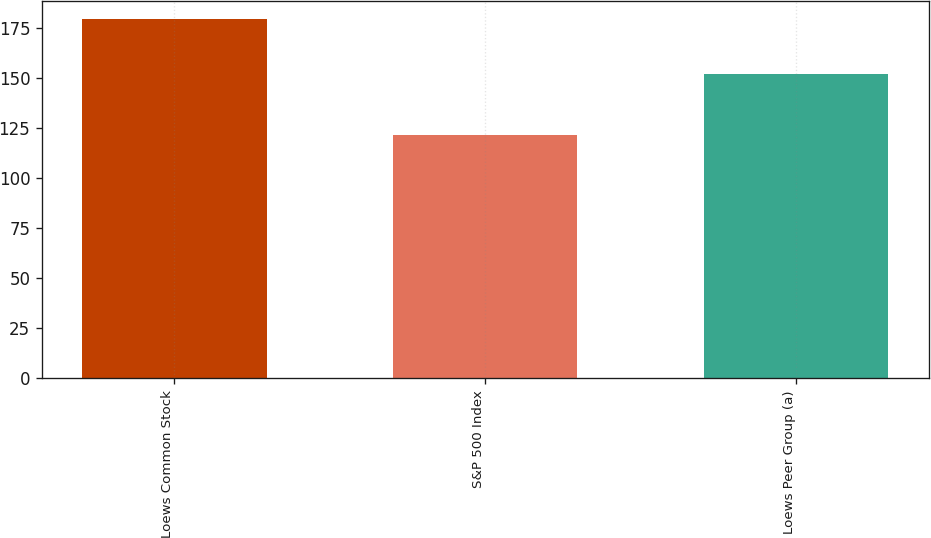Convert chart. <chart><loc_0><loc_0><loc_500><loc_500><bar_chart><fcel>Loews Common Stock<fcel>S&P 500 Index<fcel>Loews Peer Group (a)<nl><fcel>179.47<fcel>121.48<fcel>152.24<nl></chart> 